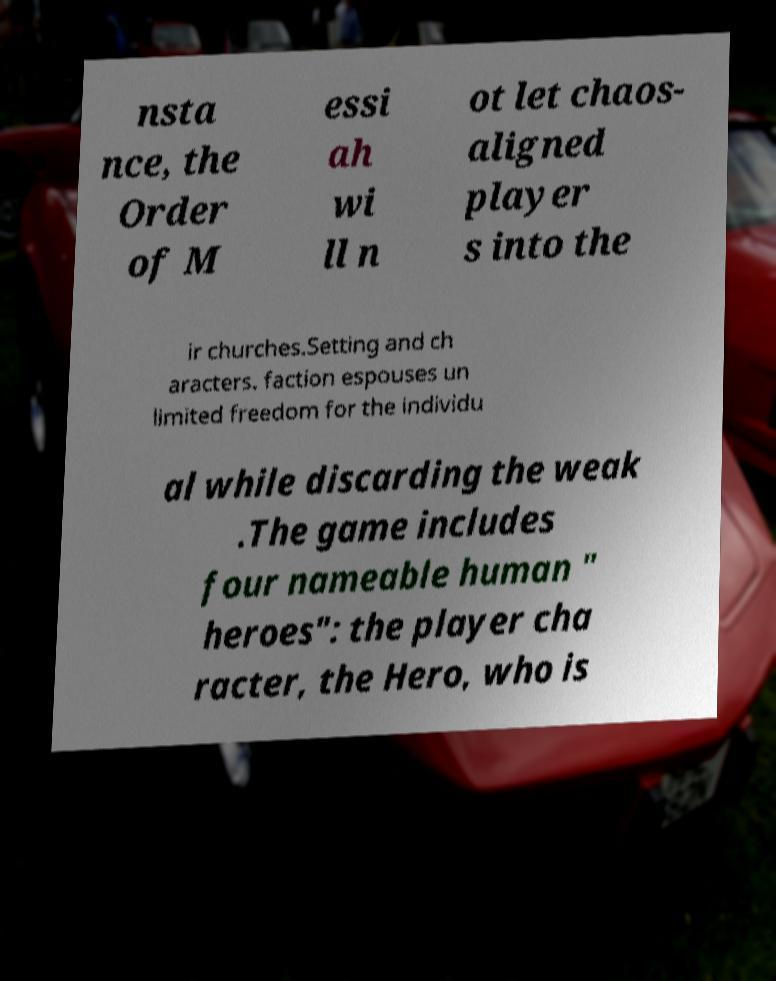Can you accurately transcribe the text from the provided image for me? nsta nce, the Order of M essi ah wi ll n ot let chaos- aligned player s into the ir churches.Setting and ch aracters. faction espouses un limited freedom for the individu al while discarding the weak .The game includes four nameable human " heroes": the player cha racter, the Hero, who is 